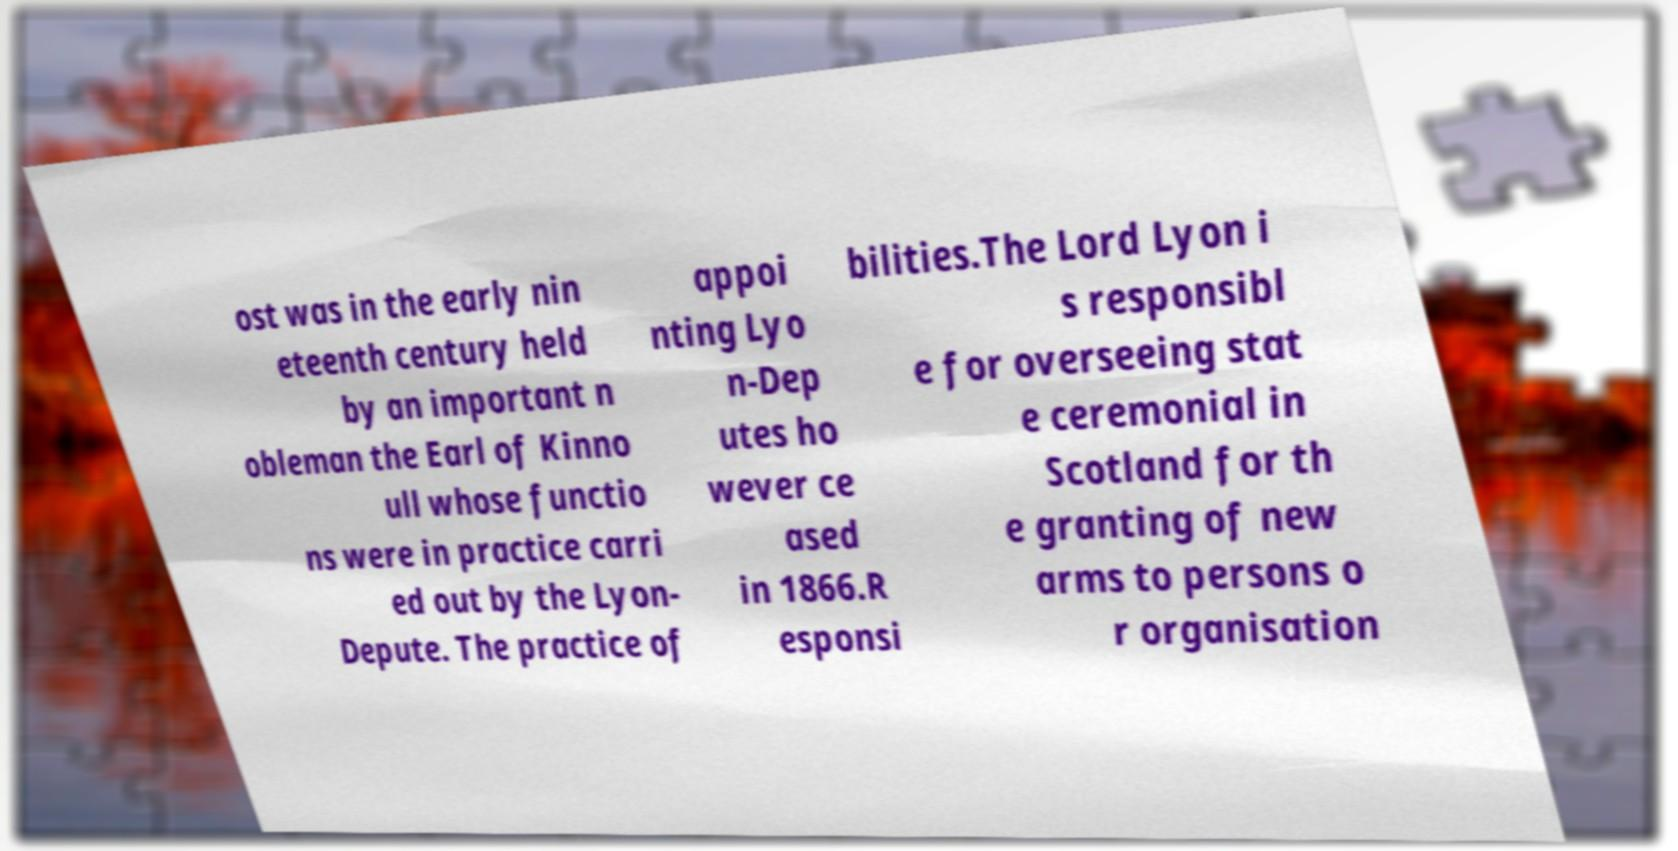For documentation purposes, I need the text within this image transcribed. Could you provide that? ost was in the early nin eteenth century held by an important n obleman the Earl of Kinno ull whose functio ns were in practice carri ed out by the Lyon- Depute. The practice of appoi nting Lyo n-Dep utes ho wever ce ased in 1866.R esponsi bilities.The Lord Lyon i s responsibl e for overseeing stat e ceremonial in Scotland for th e granting of new arms to persons o r organisation 